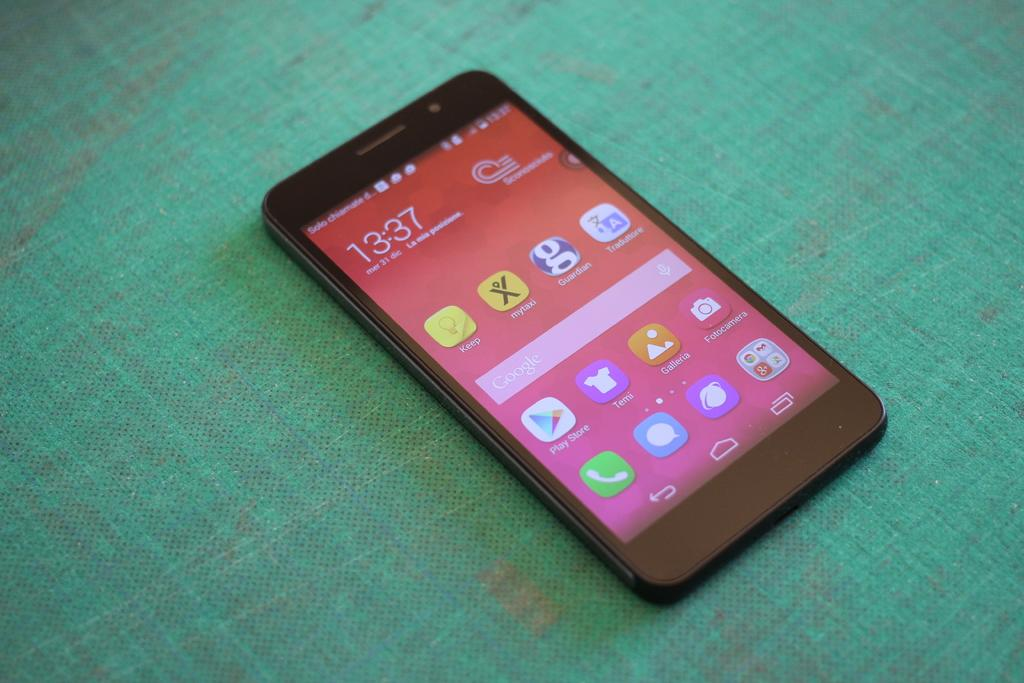Provide a one-sentence caption for the provided image. a black smart phone with the screen on and the time on it reading 13:37. 